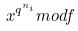Convert formula to latex. <formula><loc_0><loc_0><loc_500><loc_500>x ^ { q ^ { n _ { i } } } m o d f</formula> 